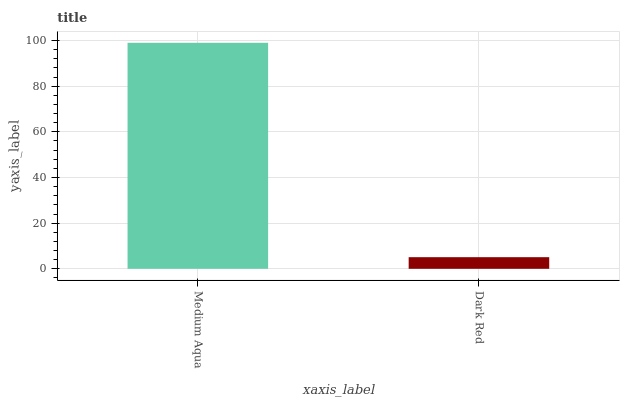Is Dark Red the minimum?
Answer yes or no. Yes. Is Medium Aqua the maximum?
Answer yes or no. Yes. Is Dark Red the maximum?
Answer yes or no. No. Is Medium Aqua greater than Dark Red?
Answer yes or no. Yes. Is Dark Red less than Medium Aqua?
Answer yes or no. Yes. Is Dark Red greater than Medium Aqua?
Answer yes or no. No. Is Medium Aqua less than Dark Red?
Answer yes or no. No. Is Medium Aqua the high median?
Answer yes or no. Yes. Is Dark Red the low median?
Answer yes or no. Yes. Is Dark Red the high median?
Answer yes or no. No. Is Medium Aqua the low median?
Answer yes or no. No. 